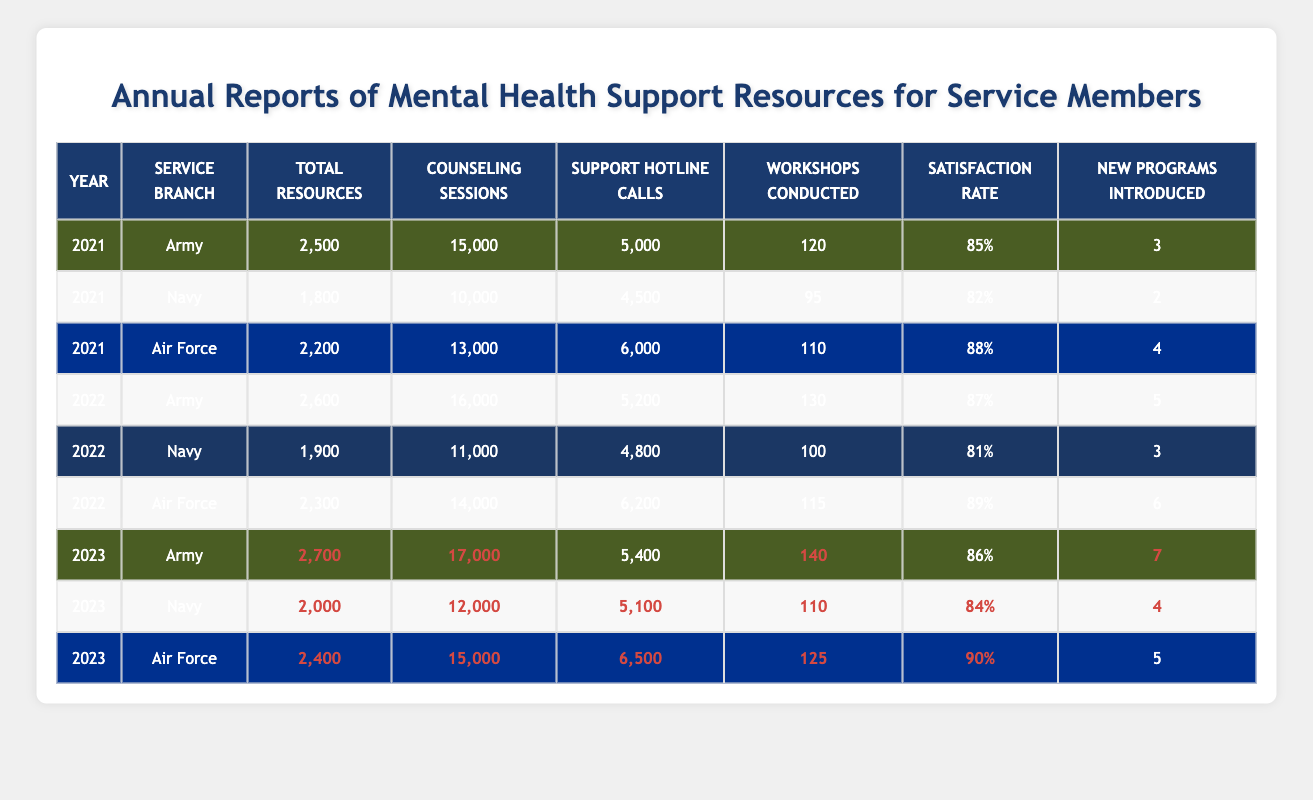What was the total number of counseling sessions conducted by the Navy in 2022? In 2022, the Navy had 11,000 counseling sessions conducted, as seen in the table.
Answer: 11,000 Which service branch had the highest satisfaction rate in 2021? According to the table, the Air Force had the highest satisfaction rate of 88%, compared to 85% for the Army and 82% for the Navy.
Answer: Air Force How many new programs were introduced by the Army from 2021 to 2022? In 2021, the Army introduced 3 new programs. In 2022, this number increased to 5. Therefore, the difference is 5 - 3 = 2.
Answer: 2 Was the total number of resources for the Navy greater in 2023 than in 2021? In 2021, the Navy had 1,800 total resources, while in 2023, it had 2,000. Since 2,000 is greater than 1,800, the statement is true.
Answer: Yes What is the average satisfaction rate across all service branches in 2022? The satisfaction rates for 2022 are Army (87%), Navy (81%), and Air Force (89%). The average rate is calculated as (87 + 81 + 89) / 3 = 85.67%.
Answer: 85.67% Which service branch conducted the most workshops in 2023? In 2023, the Army conducted 140 workshops, the Navy conducted 110, and the Air Force conducted 125. Thus, the Army had the most workshops.
Answer: Army What is the total number of hotline calls for the Air Force from 2021 to 2023? Adding the hotline calls: 6,000 (2021) + 6,200 (2022) + 6,500 (2023) = 18,700 hotline calls for the Air Force over these years.
Answer: 18,700 Did the total resources for the Army increase from 2021 to 2023? The Army had 2,500 total resources in 2021 and increased to 2,700 in 2023. Since 2,700 is greater than 2,500, the total resources increased.
Answer: Yes What percentage increase in counseling sessions did the Air Force experience from 2021 to 2023? The Air Force had 13,000 sessions in 2021 and 15,000 sessions in 2023. The increase is 15,000 - 13,000 = 2,000. The percentage increase is (2,000 / 13,000) * 100 = 15.38%.
Answer: 15.38% Which service branch had the least total resources in 2022? In 2022, the Navy had the least total resources with 1,900, compared to 2,600 for the Army and 2,300 for the Air Force.
Answer: Navy 